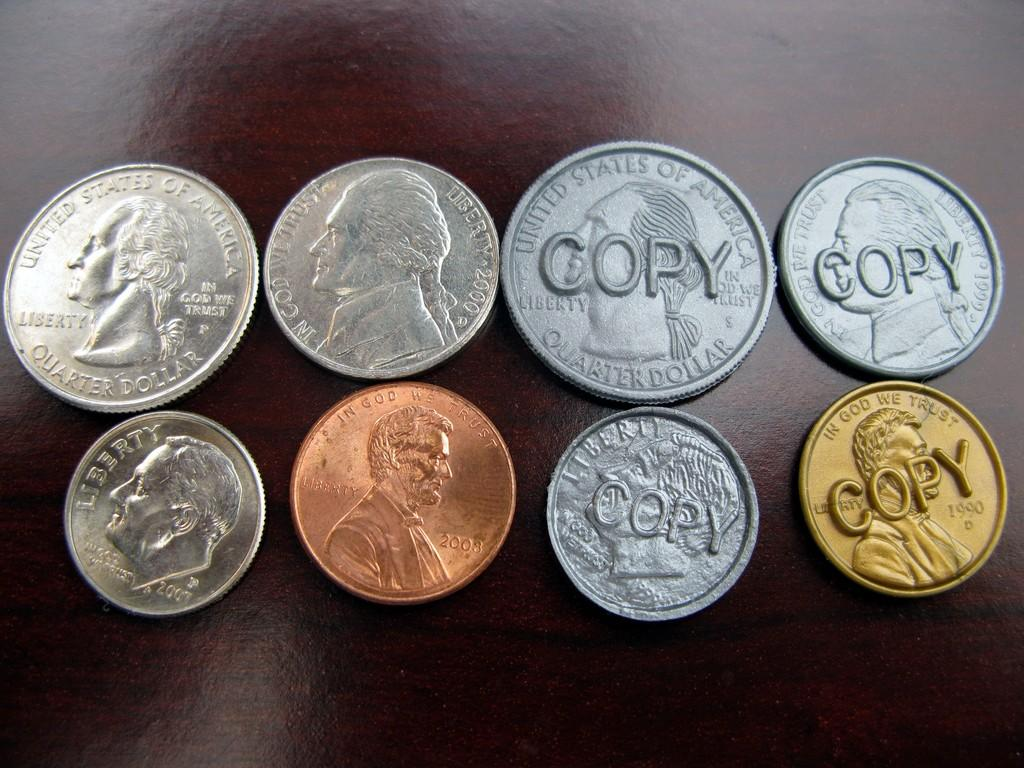Provide a one-sentence caption for the provided image. Various US coins are displayed and COPY is in front of four of them. 